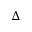Convert formula to latex. <formula><loc_0><loc_0><loc_500><loc_500>\Delta</formula> 